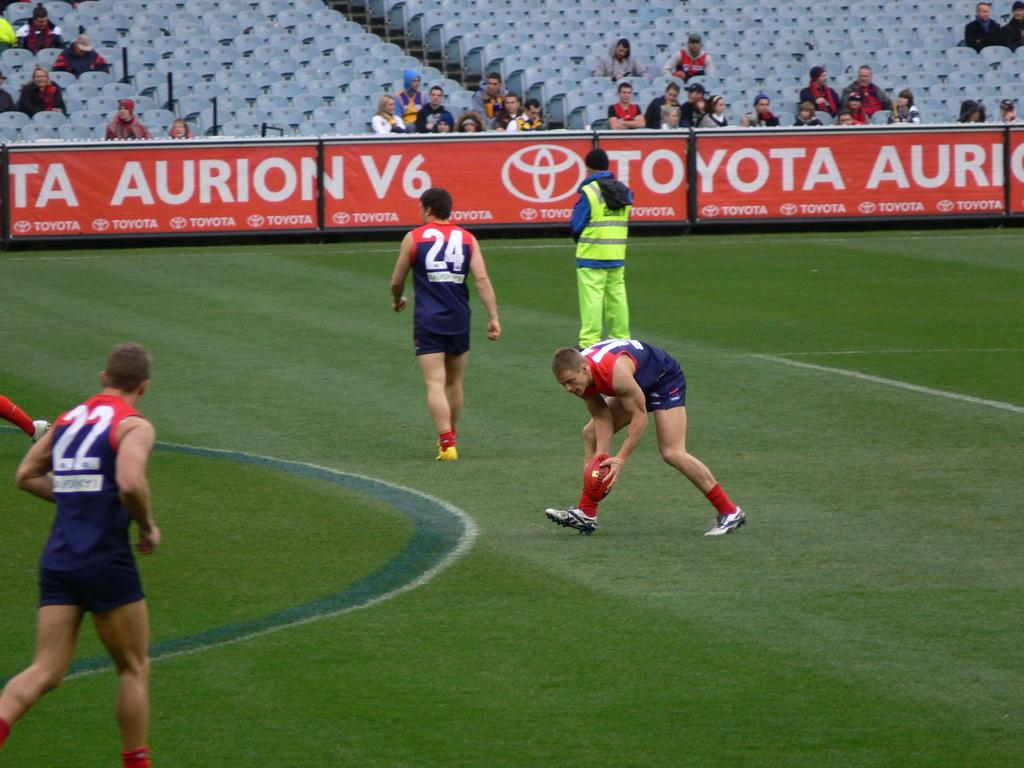<image>
Render a clear and concise summary of the photo. people on a sports field with ads for Toyota on it 